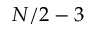<formula> <loc_0><loc_0><loc_500><loc_500>N / 2 - 3</formula> 